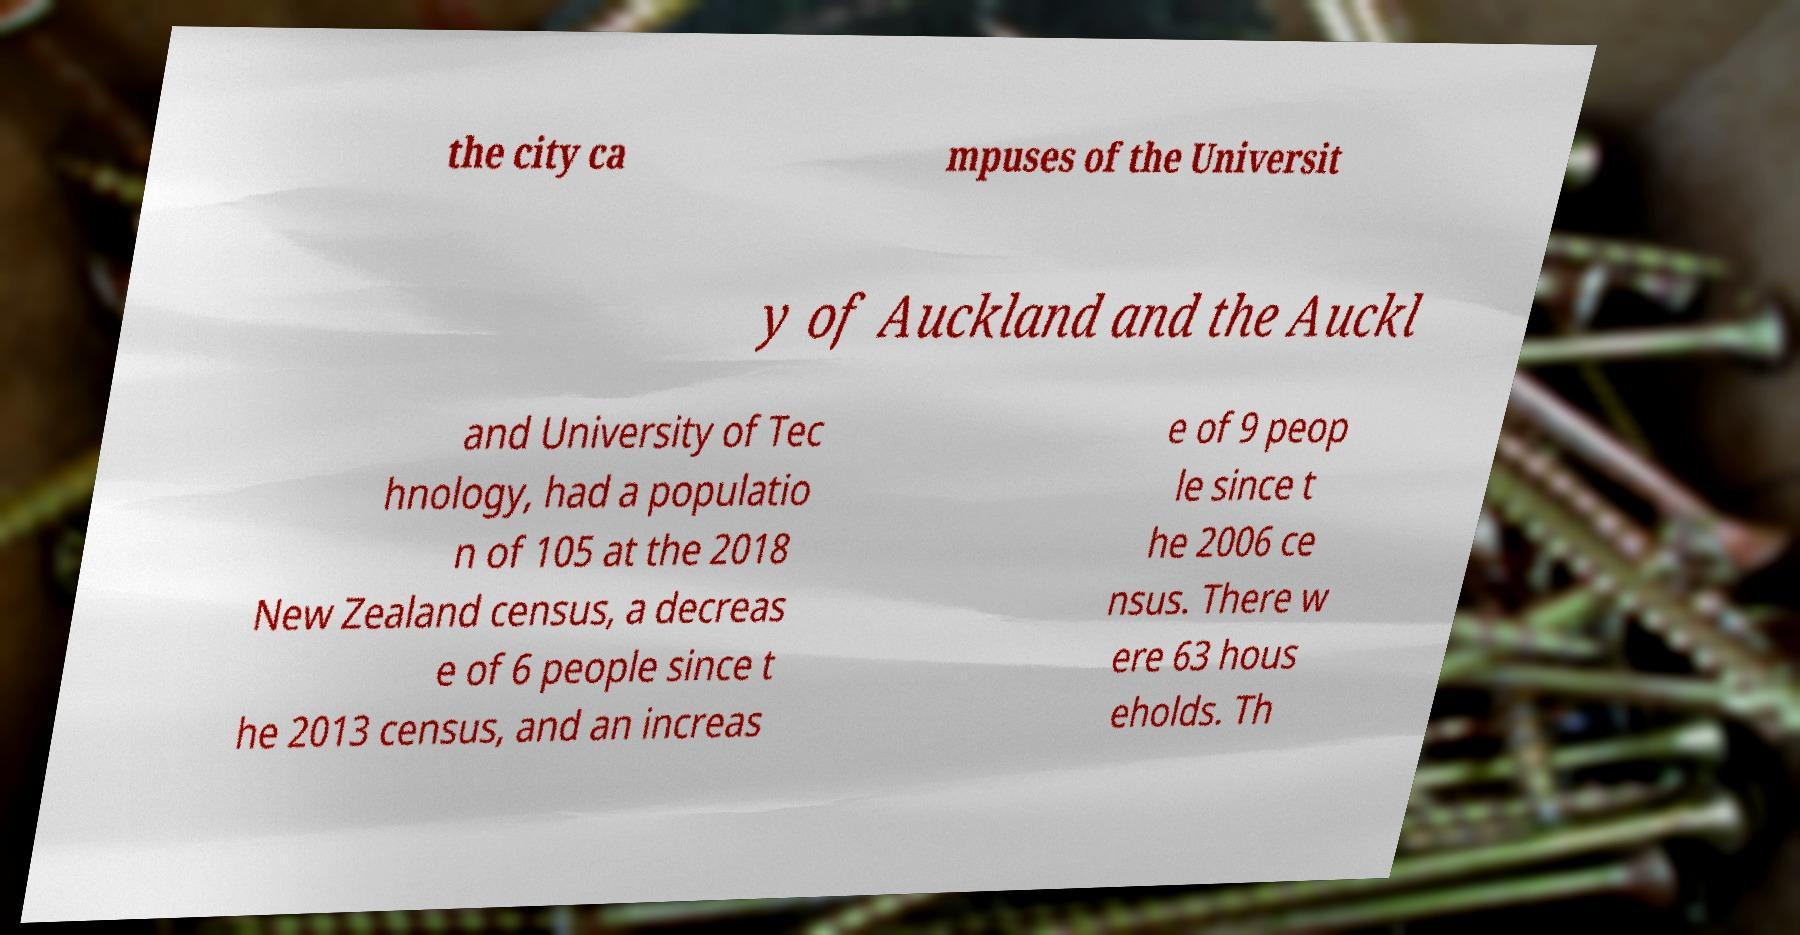What messages or text are displayed in this image? I need them in a readable, typed format. the city ca mpuses of the Universit y of Auckland and the Auckl and University of Tec hnology, had a populatio n of 105 at the 2018 New Zealand census, a decreas e of 6 people since t he 2013 census, and an increas e of 9 peop le since t he 2006 ce nsus. There w ere 63 hous eholds. Th 